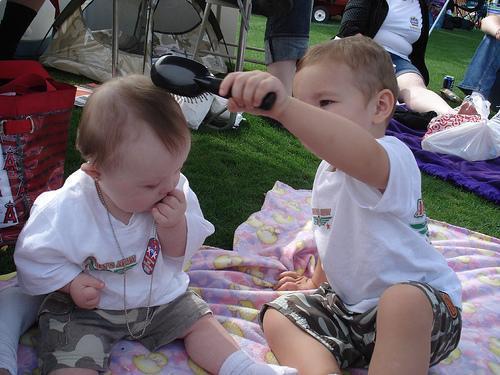What syndrome does the baby on the left have?
From the following set of four choices, select the accurate answer to respond to the question.
Options: Broken leg, torticollis, cerebral palsy, down's syndrome. Down's syndrome. 